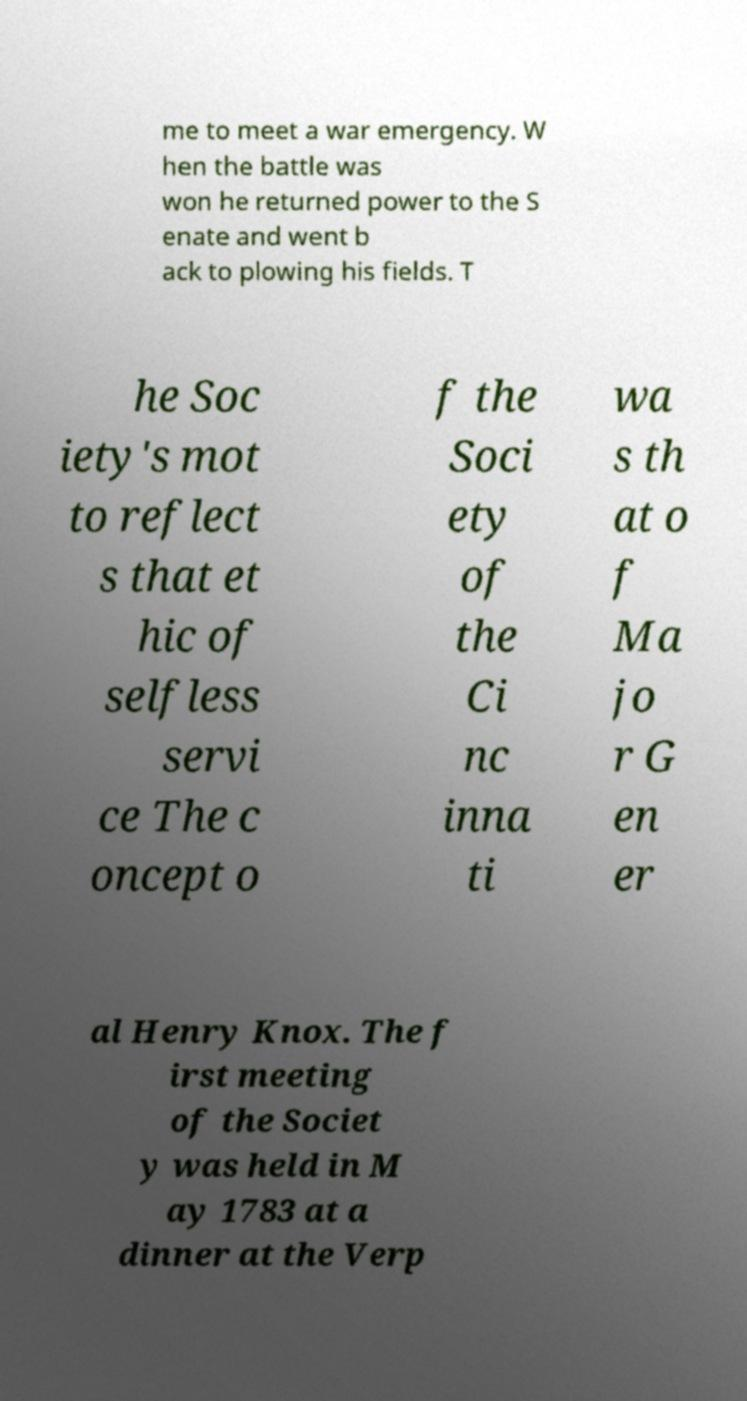Can you accurately transcribe the text from the provided image for me? me to meet a war emergency. W hen the battle was won he returned power to the S enate and went b ack to plowing his fields. T he Soc iety's mot to reflect s that et hic of selfless servi ce The c oncept o f the Soci ety of the Ci nc inna ti wa s th at o f Ma jo r G en er al Henry Knox. The f irst meeting of the Societ y was held in M ay 1783 at a dinner at the Verp 